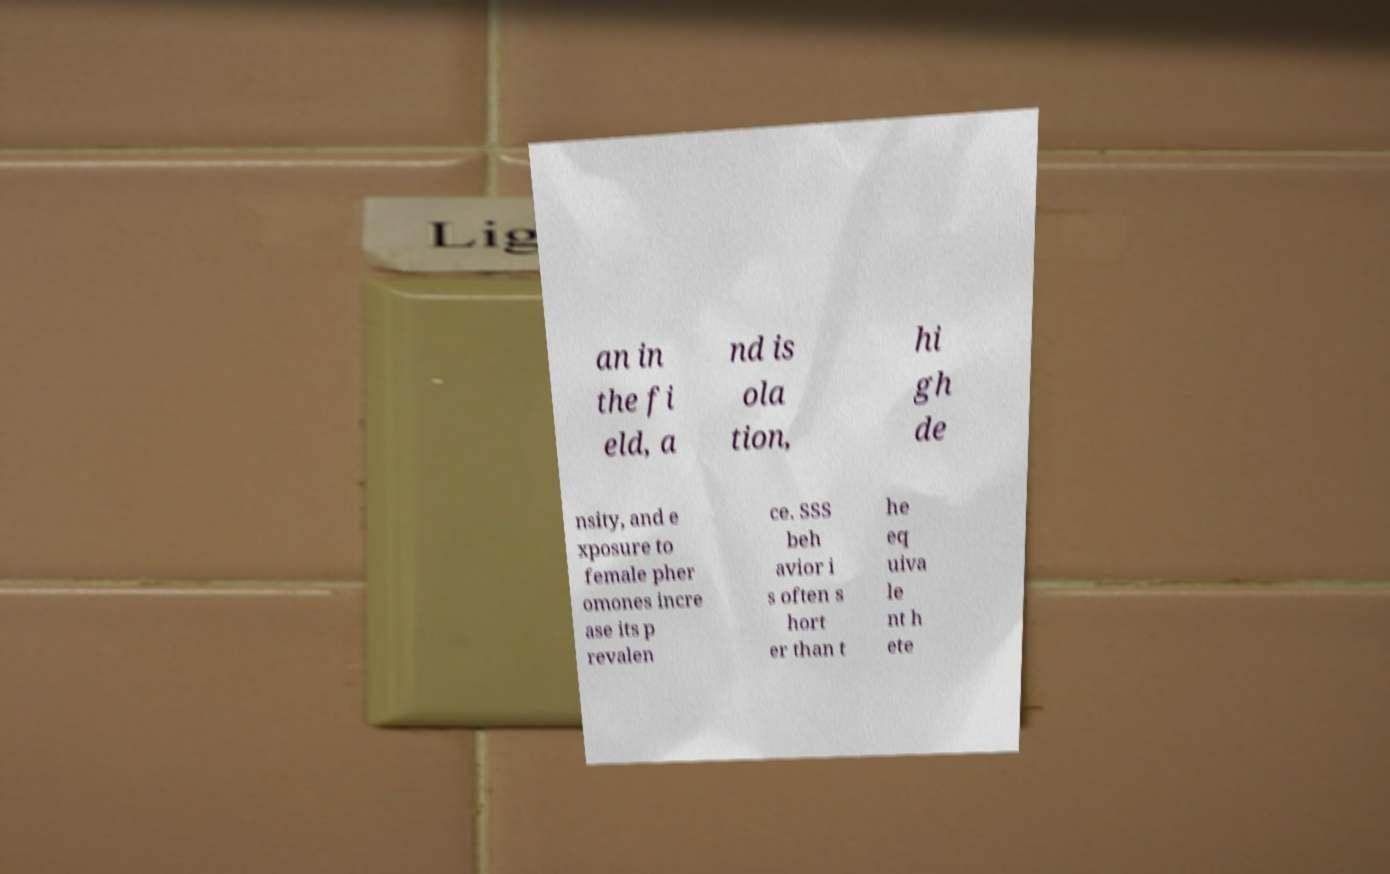For documentation purposes, I need the text within this image transcribed. Could you provide that? an in the fi eld, a nd is ola tion, hi gh de nsity, and e xposure to female pher omones incre ase its p revalen ce. SSS beh avior i s often s hort er than t he eq uiva le nt h ete 